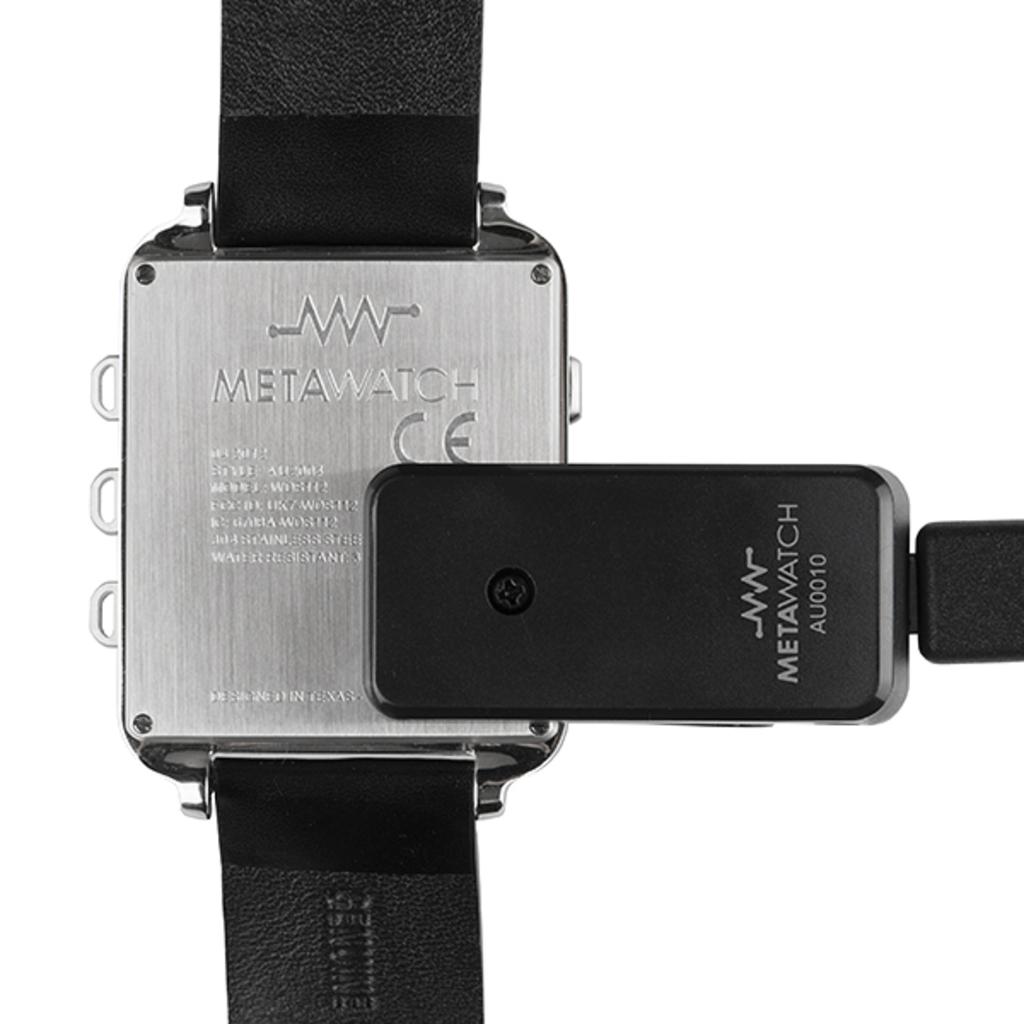What type of watch is this?
Offer a terse response. Metawatch. What model number is the metawatch?
Your answer should be compact. Au0010. 